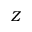Convert formula to latex. <formula><loc_0><loc_0><loc_500><loc_500>Z</formula> 